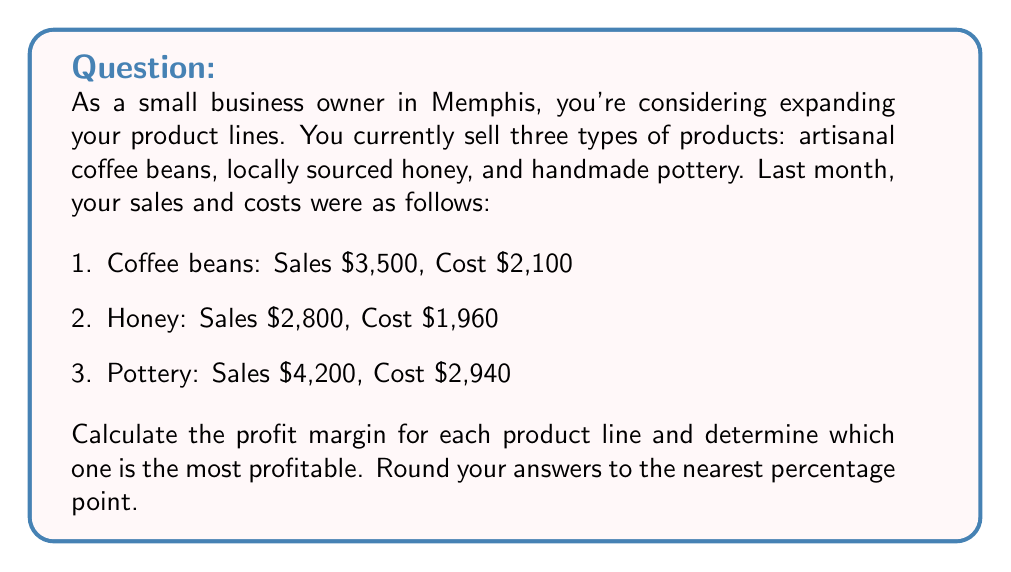Solve this math problem. To calculate the profit margin for each product line, we'll use the formula:

$$ \text{Profit Margin} = \frac{\text{Revenue} - \text{Cost}}{\text{Revenue}} \times 100\% $$

Let's calculate for each product:

1. Coffee beans:
   $$ \text{Profit Margin} = \frac{3500 - 2100}{3500} \times 100\% = \frac{1400}{3500} \times 100\% \approx 40\% $$

2. Honey:
   $$ \text{Profit Margin} = \frac{2800 - 1960}{2800} \times 100\% = \frac{840}{2800} \times 100\% = 30\% $$

3. Pottery:
   $$ \text{Profit Margin} = \frac{4200 - 2940}{4200} \times 100\% = \frac{1260}{4200} \times 100\% = 30\% $$

Comparing the profit margins:
Coffee beans: 40%
Honey: 30%
Pottery: 30%

The coffee beans product line has the highest profit margin at 40%.
Answer: Coffee beans (40%) 